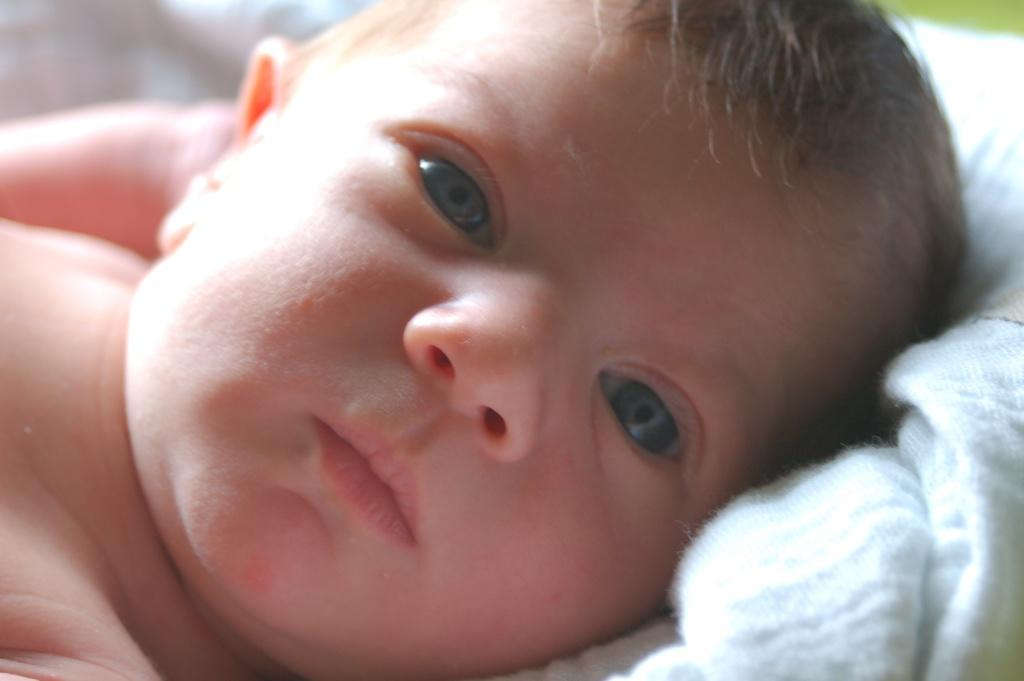What is the main subject of the image? There is a baby boy in the image. What is the baby boy doing in the image? The baby boy is lying down. What is covering the baby boy in the image? There is a blanket in the image. What color is the blanket? The blanket is white in color. What type of disease is the baby boy suffering from in the image? There is no indication of any disease in the image; the baby boy is simply lying down with a white blanket. 